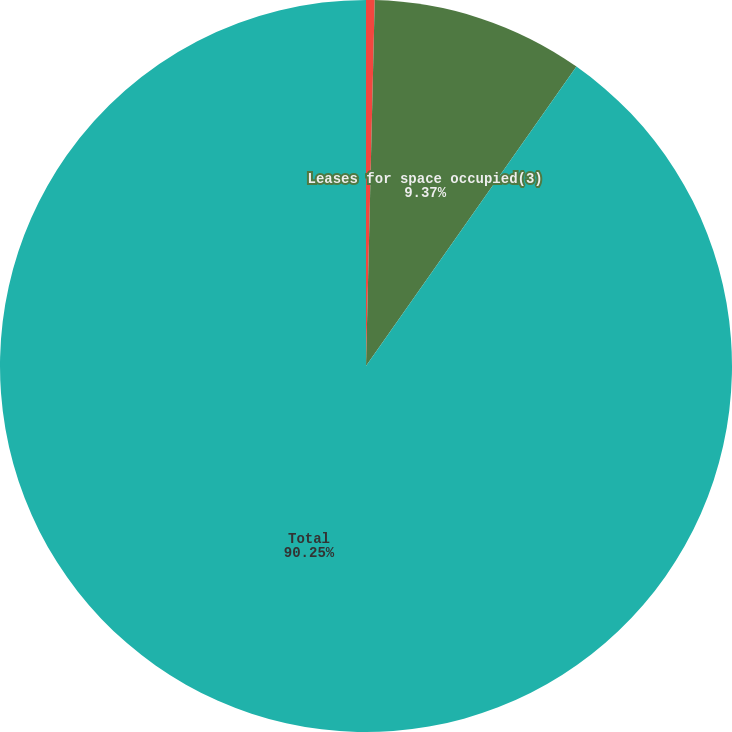<chart> <loc_0><loc_0><loc_500><loc_500><pie_chart><fcel>Scheduled long-term debt<fcel>Leases for space occupied(3)<fcel>Total<nl><fcel>0.38%<fcel>9.37%<fcel>90.25%<nl></chart> 